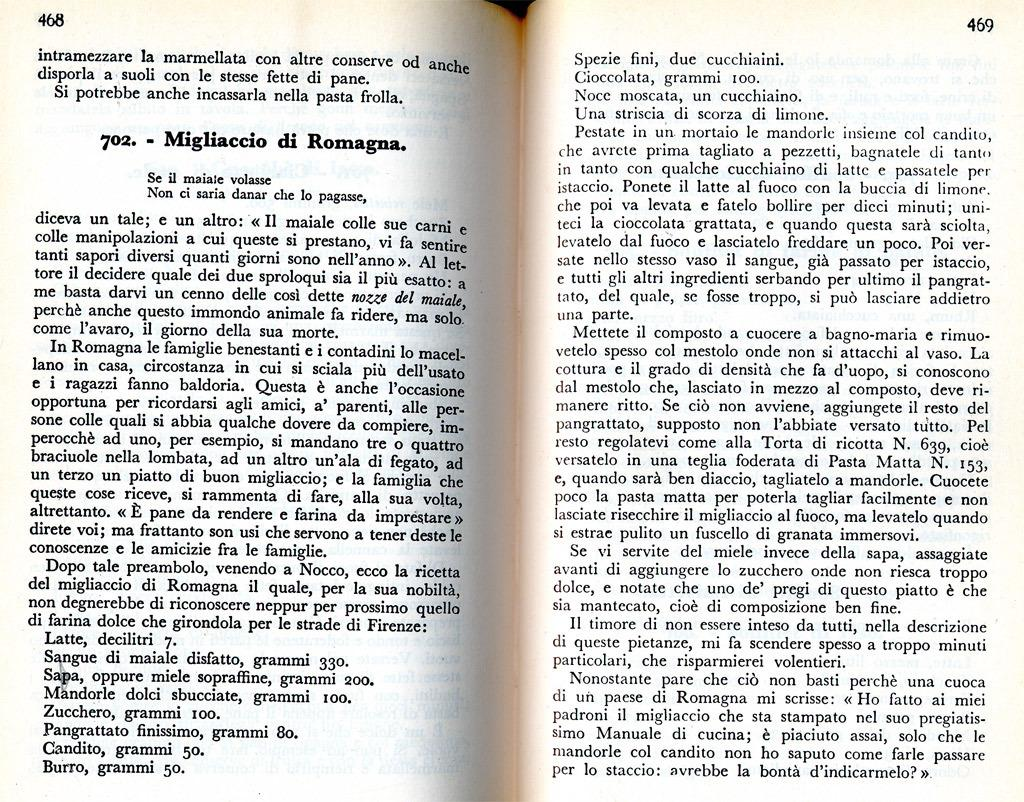<image>
Share a concise interpretation of the image provided. A book written in Italian is opened to pages 468 and 469. 